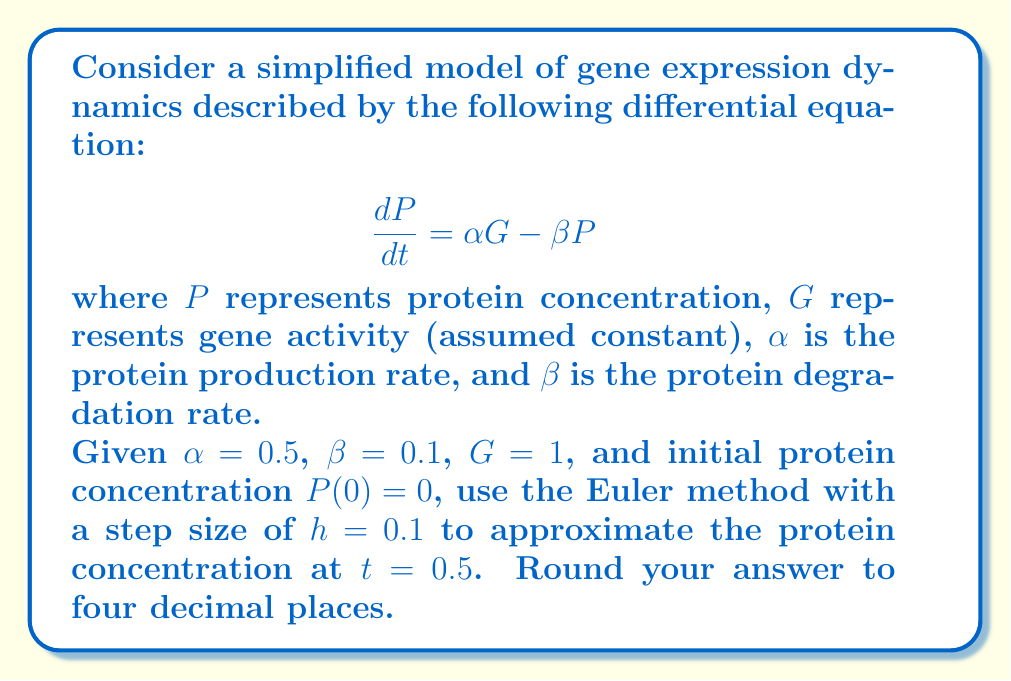Can you solve this math problem? To solve this problem using the Euler method, we'll follow these steps:

1) The Euler method for approximating solutions to differential equations is given by:

   $$ y_{n+1} = y_n + h f(t_n, y_n) $$

   where $h$ is the step size, and $f(t, y)$ is the right-hand side of the differential equation.

2) In our case, $f(t, P) = \alpha G - \beta P = 0.5 \cdot 1 - 0.1P = 0.5 - 0.1P$

3) We need to make 5 steps of size $h = 0.1$ to reach $t = 0.5$. Let's calculate each step:

   Step 1 ($t = 0.1$):
   $P_1 = P_0 + h(0.5 - 0.1P_0) = 0 + 0.1(0.5 - 0.1 \cdot 0) = 0.0500$

   Step 2 ($t = 0.2$):
   $P_2 = P_1 + h(0.5 - 0.1P_1) = 0.0500 + 0.1(0.5 - 0.1 \cdot 0.0500) = 0.0995$

   Step 3 ($t = 0.3$):
   $P_3 = P_2 + h(0.5 - 0.1P_2) = 0.0995 + 0.1(0.5 - 0.1 \cdot 0.0995) = 0.1486$

   Step 4 ($t = 0.4$):
   $P_4 = P_3 + h(0.5 - 0.1P_3) = 0.1486 + 0.1(0.5 - 0.1 \cdot 0.1486) = 0.1973$

   Step 5 ($t = 0.5$):
   $P_5 = P_4 + h(0.5 - 0.1P_4) = 0.1973 + 0.1(0.5 - 0.1 \cdot 0.1973) = 0.2456$

4) Rounding to four decimal places, we get 0.2456.
Answer: 0.2456 